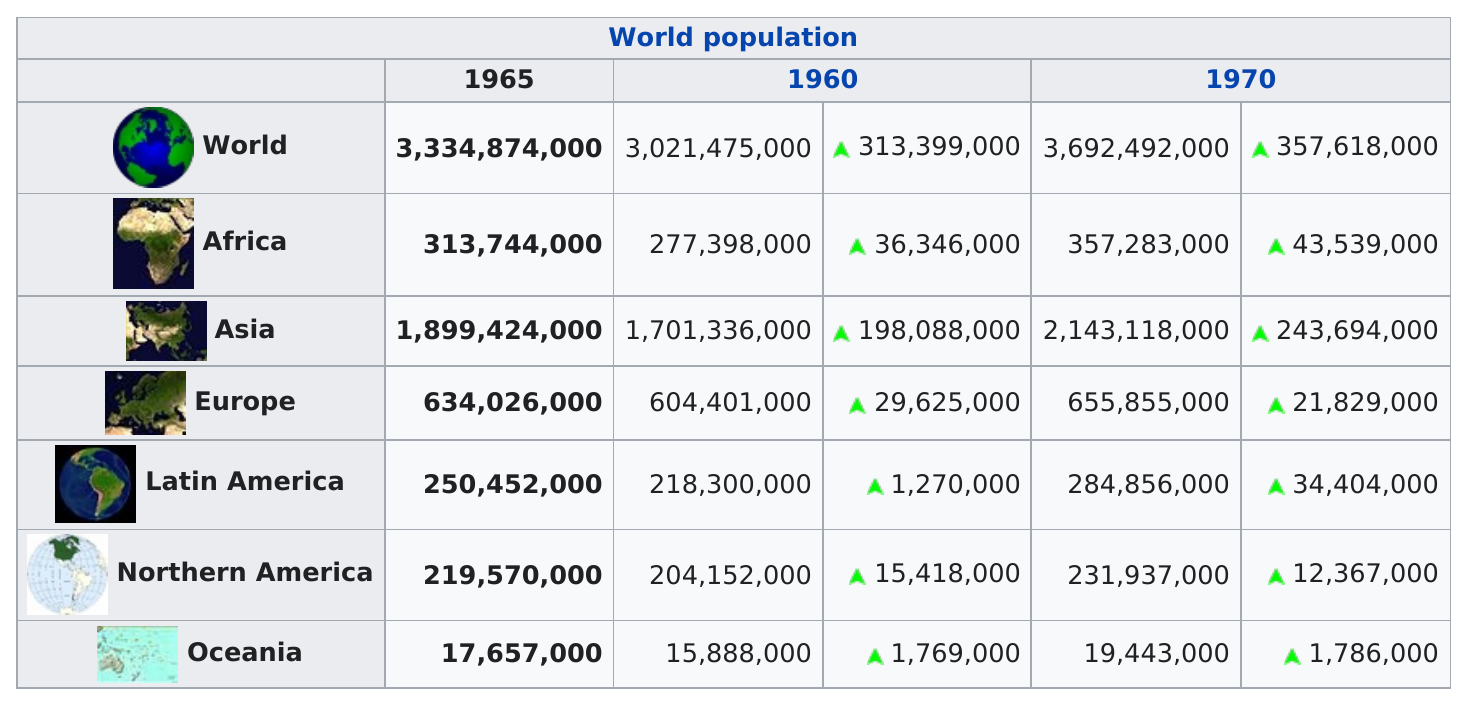Point out several critical features in this image. In 1965, Asia was the most populous continent in the world. In 1970, Asia had the highest population of all the continents. Four areas achieved population sizes of more than 250,000,000 people in 1970. Between 1965 and 1970, the population of Latin America grew by 34,404,000. 